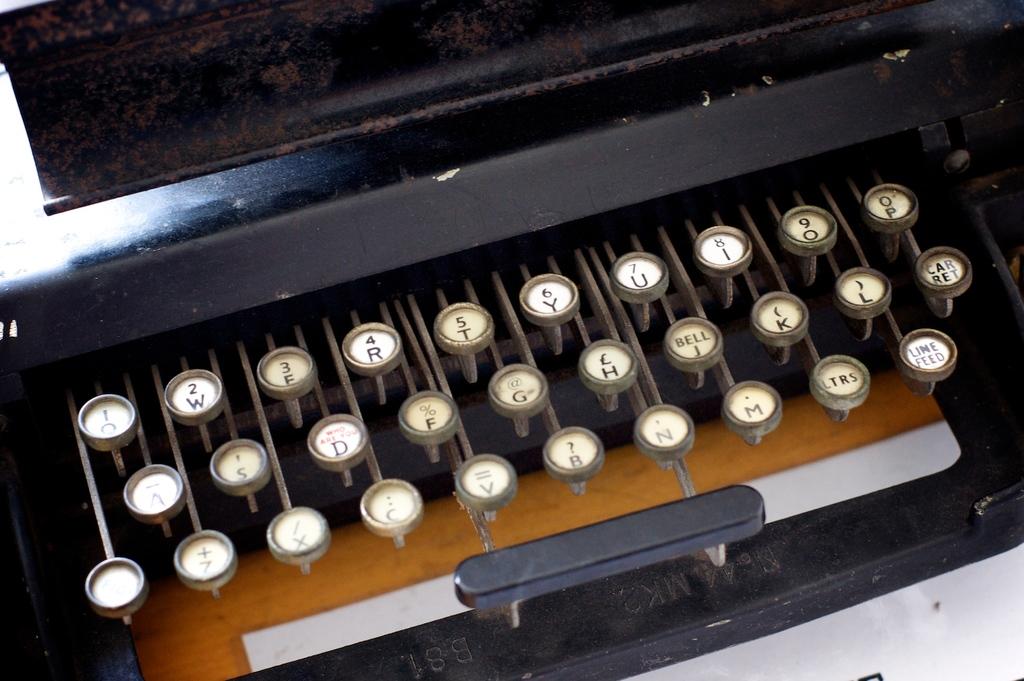What numbers are on this type writer?
Offer a terse response. 1 2 3 4 5 6 7 8 9 0. Is there a "b" key on this?
Your answer should be very brief. Yes. 